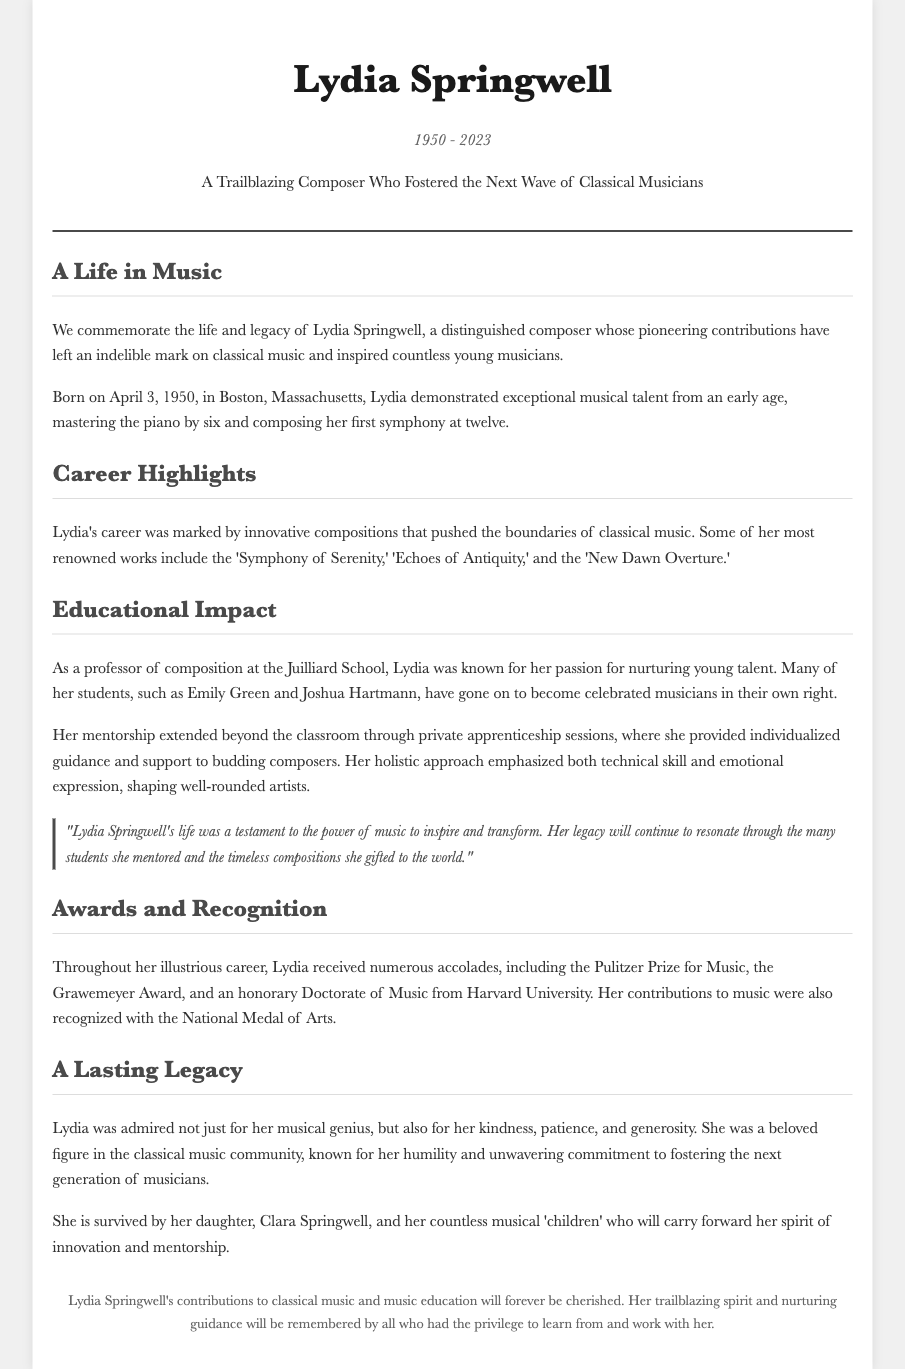What was Lydia Springwell's birth date? The document states Lydia was born on April 3, 1950.
Answer: April 3, 1950 What is one of Lydia Springwell's renowned compositions? The document lists several of her renowned works, one of which is 'Symphony of Serenity.'
Answer: Symphony of Serenity Where did Lydia teach composition? The document mentions she was a professor at the Juilliard School.
Answer: Juilliard School Which prestigious award did Lydia receive? The document states that she received the Pulitzer Prize for Music among other accolades.
Answer: Pulitzer Prize for Music How many students are specifically mentioned in the document? The document refers to two students by name: Emily Green and Joshua Hartmann.
Answer: Two What impact did Lydia's mentorship have on her students? The document describes many of her students as having become celebrated musicians.
Answer: Celebrated musicians What year does the document indicate Lydia Springwell passed away? It mentions she passed away in 2023.
Answer: 2023 Who survived Lydia Springwell? The document states she is survived by her daughter, Clara Springwell.
Answer: Clara Springwell What was Lydia's approach to mentoring students? The document describes her holistic approach that emphasized both technical skill and emotional expression.
Answer: Holistic approach 